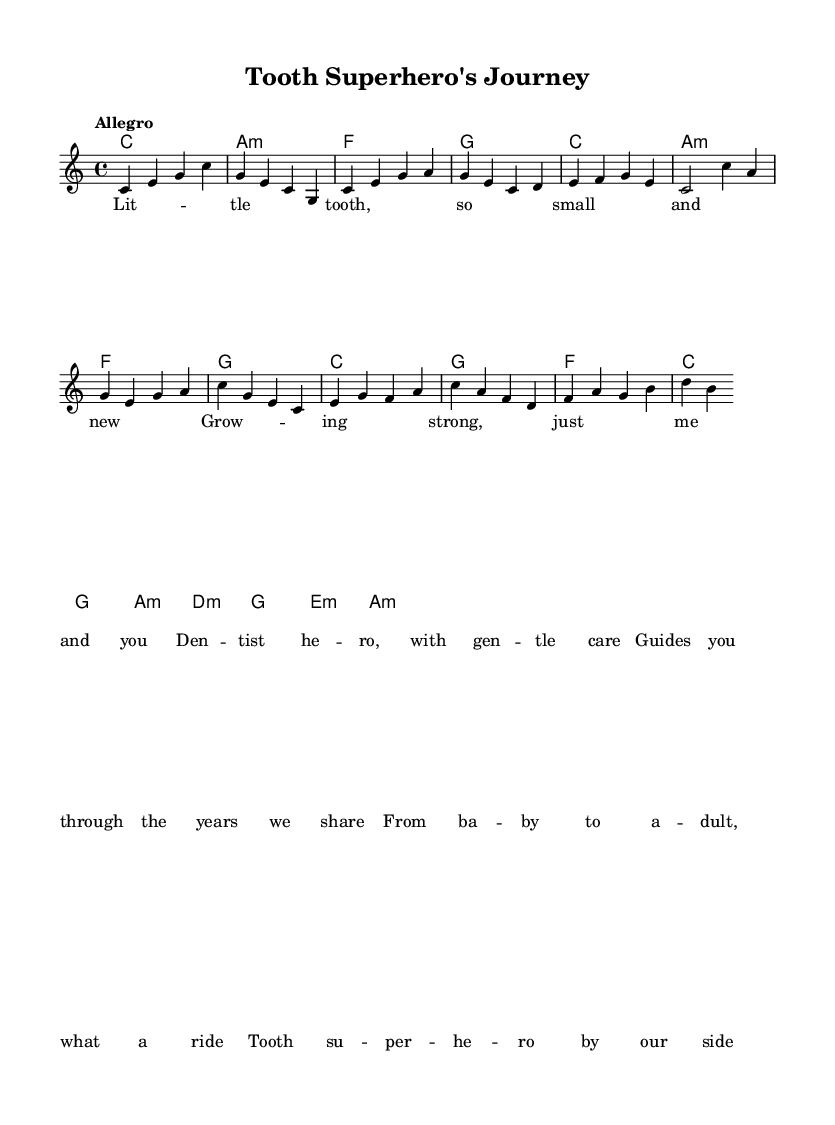What is the key signature of this music? The key signature is C major, which has no sharps or flats.
Answer: C major What is the time signature of this music? The time signature is specified as 4/4, indicating four beats per measure.
Answer: 4/4 What is the tempo marking for the piece? The tempo marking is "Allegro," which indicates a fast and lively pace.
Answer: Allegro How many measures are in the verse section? The verse section consists of four measures, as indicated in the melody line.
Answer: 4 Which chord is played during the chorus' first measure? The first measure of the chorus has an F major chord, indicated in the harmonies.
Answer: F What is the general theme of the lyrics in this music? The lyrics describe the growth journey of a tooth from baby to adult, emphasizing care and guidance.
Answer: Journey of a tooth What emotion or theme is evoked by the phrase "Tooth superhero by our side"? This phrase evokes feelings of safety and support, highlighting the dentist's role as a caregiver and protector for teeth.
Answer: Safety and support 